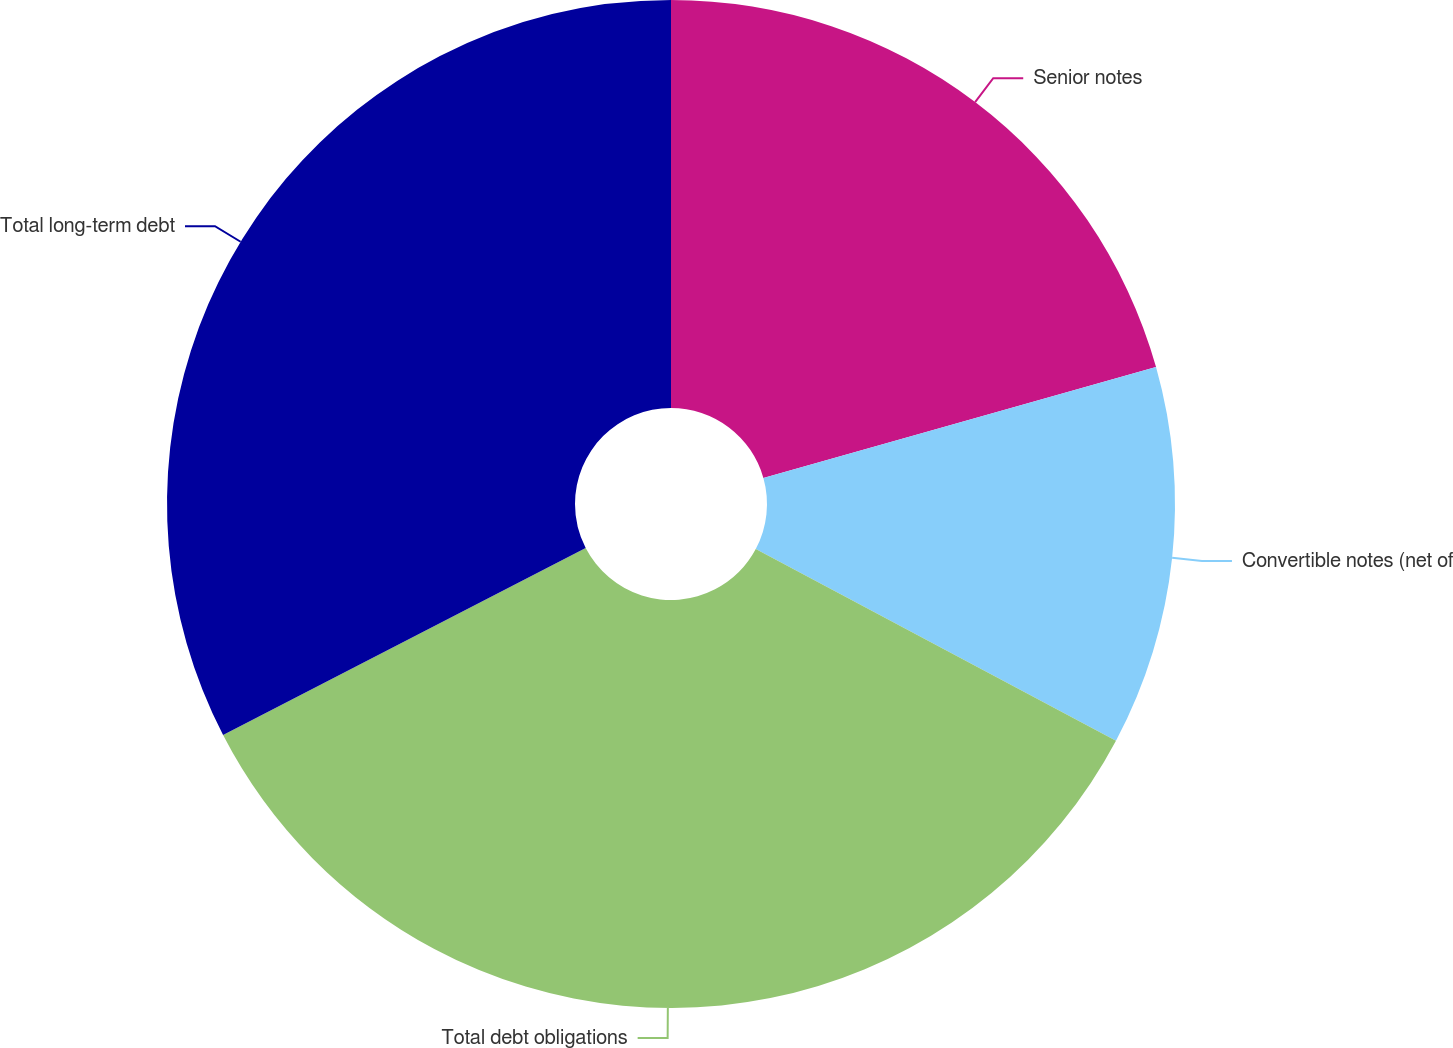<chart> <loc_0><loc_0><loc_500><loc_500><pie_chart><fcel>Senior notes<fcel>Convertible notes (net of<fcel>Total debt obligations<fcel>Total long-term debt<nl><fcel>20.62%<fcel>12.16%<fcel>34.64%<fcel>32.58%<nl></chart> 